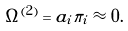Convert formula to latex. <formula><loc_0><loc_0><loc_500><loc_500>\Omega ^ { ( 2 ) } = a _ { i } \pi _ { i } \approx 0 .</formula> 